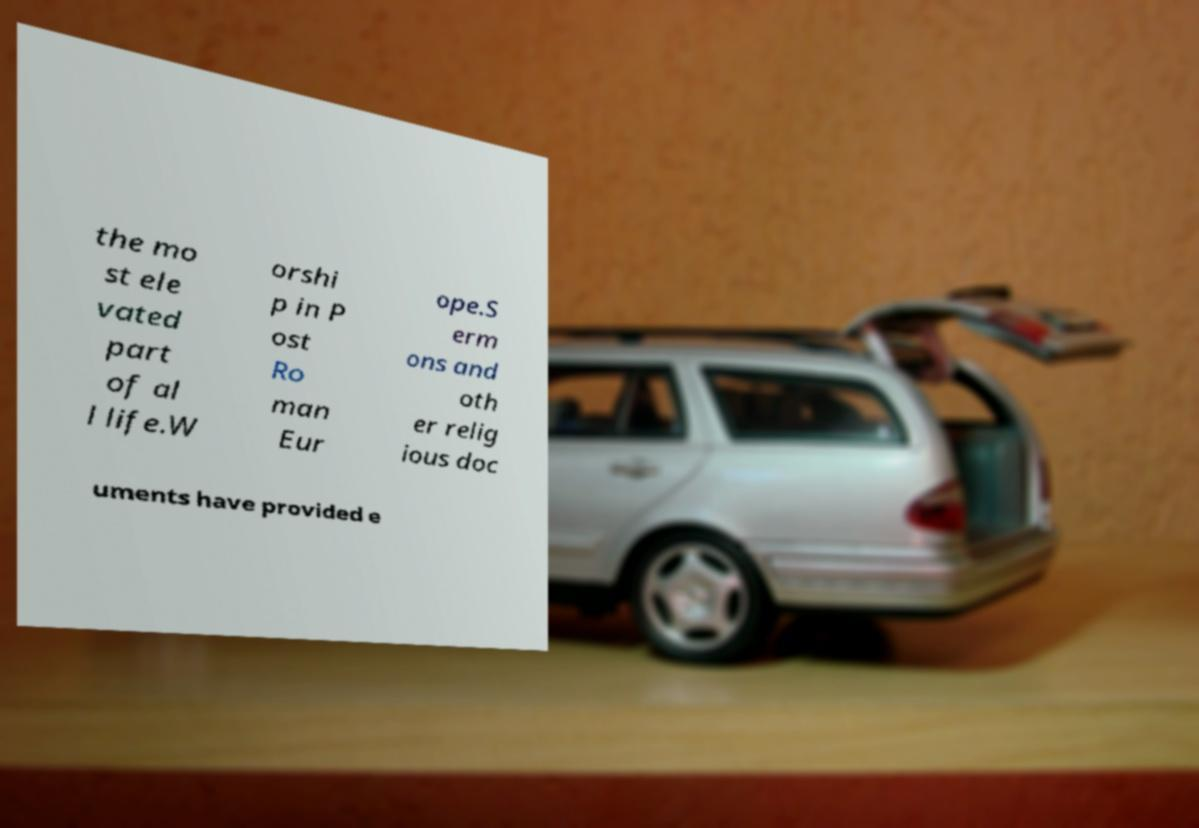For documentation purposes, I need the text within this image transcribed. Could you provide that? the mo st ele vated part of al l life.W orshi p in P ost Ro man Eur ope.S erm ons and oth er relig ious doc uments have provided e 